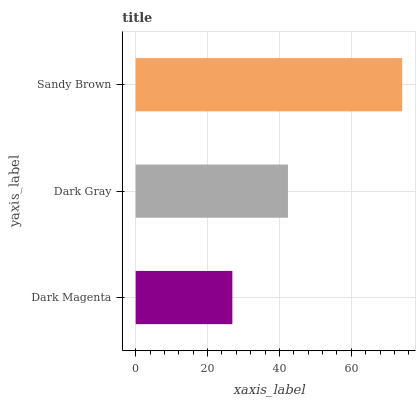Is Dark Magenta the minimum?
Answer yes or no. Yes. Is Sandy Brown the maximum?
Answer yes or no. Yes. Is Dark Gray the minimum?
Answer yes or no. No. Is Dark Gray the maximum?
Answer yes or no. No. Is Dark Gray greater than Dark Magenta?
Answer yes or no. Yes. Is Dark Magenta less than Dark Gray?
Answer yes or no. Yes. Is Dark Magenta greater than Dark Gray?
Answer yes or no. No. Is Dark Gray less than Dark Magenta?
Answer yes or no. No. Is Dark Gray the high median?
Answer yes or no. Yes. Is Dark Gray the low median?
Answer yes or no. Yes. Is Sandy Brown the high median?
Answer yes or no. No. Is Dark Magenta the low median?
Answer yes or no. No. 